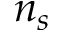Convert formula to latex. <formula><loc_0><loc_0><loc_500><loc_500>n _ { s }</formula> 